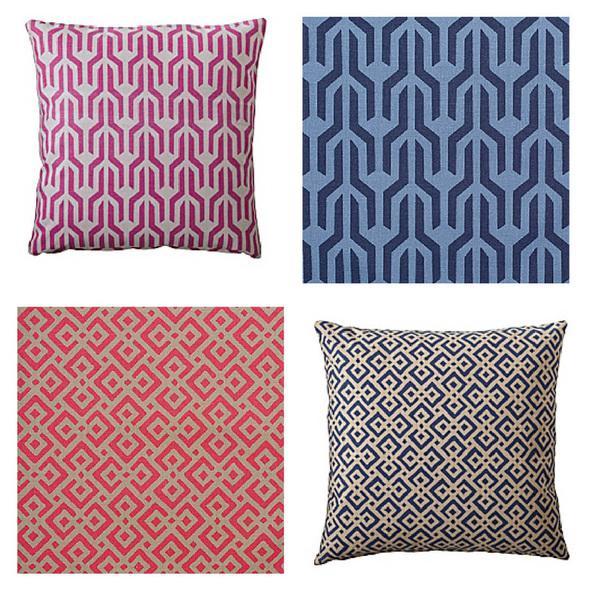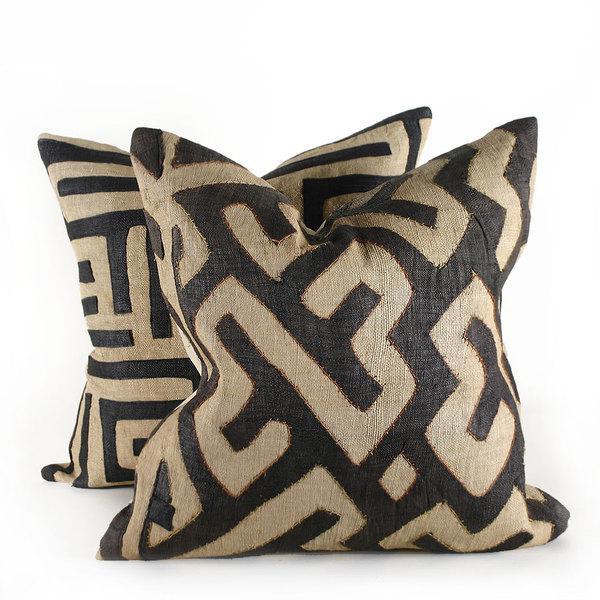The first image is the image on the left, the second image is the image on the right. Examine the images to the left and right. Is the description "There are no more than two pillows in each image." accurate? Answer yes or no. No. 